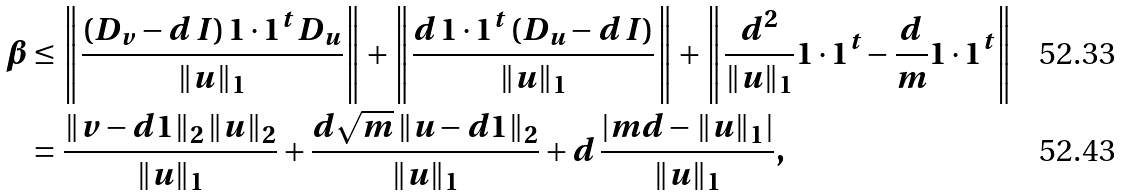<formula> <loc_0><loc_0><loc_500><loc_500>\beta & \leq \left \| \frac { ( D _ { v } - d \, I ) \, { 1 } \cdot { 1 } ^ { t } \, D _ { u } } { \| u \| _ { 1 } } \right \| + \left \| \frac { d \, { 1 } \cdot { 1 } ^ { t } \, ( D _ { u } - d \, I ) } { \| u \| _ { 1 } } \right \| + \left \| \frac { d ^ { 2 } } { \| u \| _ { 1 } } { 1 } \cdot { 1 } ^ { t } - \frac { d } { m } { 1 } \cdot { 1 } ^ { t } \right \| \\ & = \frac { \| v - d { 1 } \| _ { 2 } \, \| u \| _ { 2 } } { \| u \| _ { 1 } } + \frac { d \sqrt { m } \, \| u - d { 1 } \| _ { 2 } } { \| u \| _ { 1 } } + d \, \frac { \left | m d - \| u \| _ { 1 } \right | } { \| u \| _ { 1 } } ,</formula> 